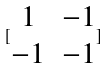<formula> <loc_0><loc_0><loc_500><loc_500>[ \begin{matrix} 1 & - 1 \\ - 1 & - 1 \end{matrix} ]</formula> 